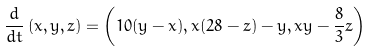<formula> <loc_0><loc_0><loc_500><loc_500>\frac { d } { d t } \left ( x , y , z \right ) = \left ( 1 0 ( y - x ) , x ( 2 8 - z ) - y , x y - \frac { 8 } { 3 } z \right )</formula> 